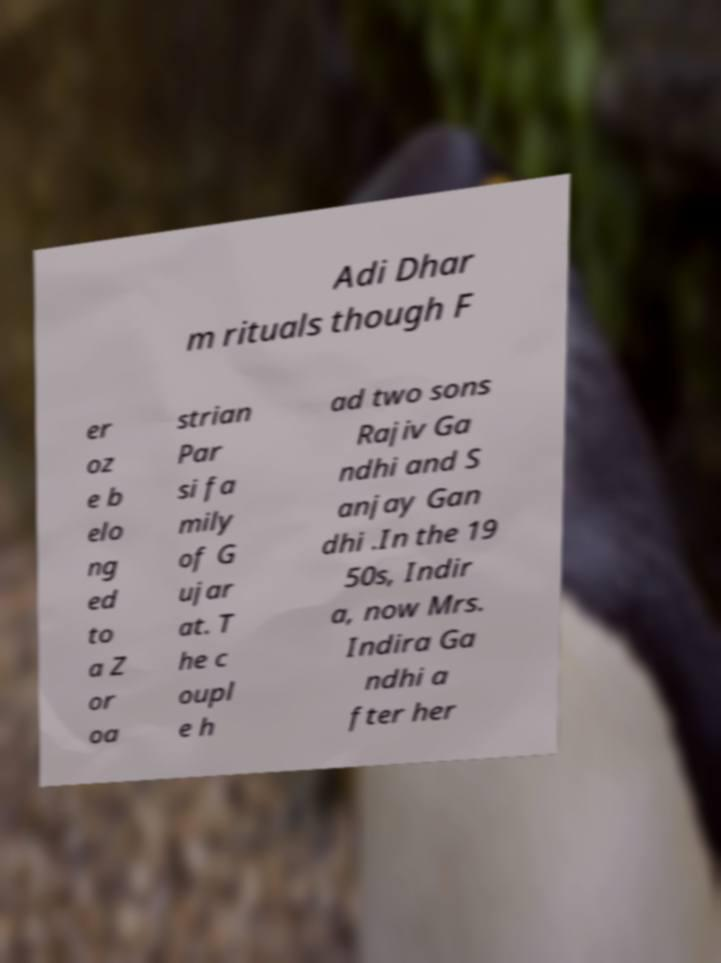Can you accurately transcribe the text from the provided image for me? Adi Dhar m rituals though F er oz e b elo ng ed to a Z or oa strian Par si fa mily of G ujar at. T he c oupl e h ad two sons Rajiv Ga ndhi and S anjay Gan dhi .In the 19 50s, Indir a, now Mrs. Indira Ga ndhi a fter her 